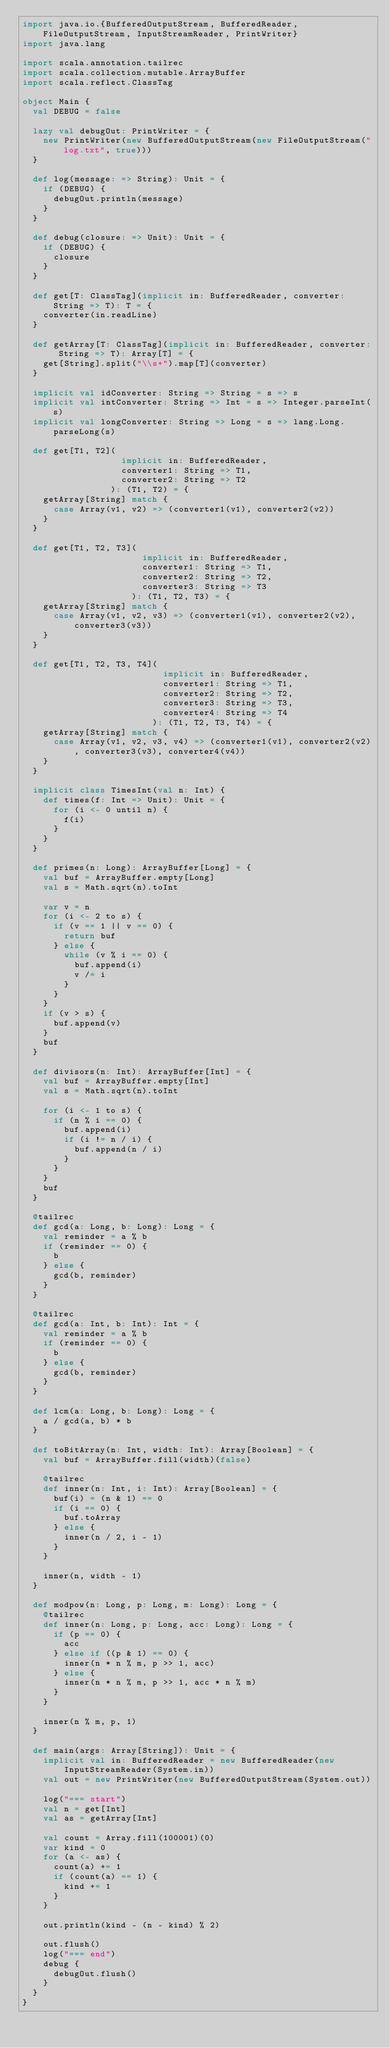Convert code to text. <code><loc_0><loc_0><loc_500><loc_500><_Scala_>import java.io.{BufferedOutputStream, BufferedReader, FileOutputStream, InputStreamReader, PrintWriter}
import java.lang

import scala.annotation.tailrec
import scala.collection.mutable.ArrayBuffer
import scala.reflect.ClassTag

object Main {
  val DEBUG = false

  lazy val debugOut: PrintWriter = {
    new PrintWriter(new BufferedOutputStream(new FileOutputStream("log.txt", true)))
  }

  def log(message: => String): Unit = {
    if (DEBUG) {
      debugOut.println(message)
    }
  }

  def debug(closure: => Unit): Unit = {
    if (DEBUG) {
      closure
    }
  }

  def get[T: ClassTag](implicit in: BufferedReader, converter: String => T): T = {
    converter(in.readLine)
  }

  def getArray[T: ClassTag](implicit in: BufferedReader, converter: String => T): Array[T] = {
    get[String].split("\\s+").map[T](converter)
  }

  implicit val idConverter: String => String = s => s
  implicit val intConverter: String => Int = s => Integer.parseInt(s)
  implicit val longConverter: String => Long = s => lang.Long.parseLong(s)

  def get[T1, T2](
                   implicit in: BufferedReader,
                   converter1: String => T1,
                   converter2: String => T2
                 ): (T1, T2) = {
    getArray[String] match {
      case Array(v1, v2) => (converter1(v1), converter2(v2))
    }
  }

  def get[T1, T2, T3](
                       implicit in: BufferedReader,
                       converter1: String => T1,
                       converter2: String => T2,
                       converter3: String => T3
                     ): (T1, T2, T3) = {
    getArray[String] match {
      case Array(v1, v2, v3) => (converter1(v1), converter2(v2), converter3(v3))
    }
  }

  def get[T1, T2, T3, T4](
                           implicit in: BufferedReader,
                           converter1: String => T1,
                           converter2: String => T2,
                           converter3: String => T3,
                           converter4: String => T4
                         ): (T1, T2, T3, T4) = {
    getArray[String] match {
      case Array(v1, v2, v3, v4) => (converter1(v1), converter2(v2), converter3(v3), converter4(v4))
    }
  }

  implicit class TimesInt(val n: Int) {
    def times(f: Int => Unit): Unit = {
      for (i <- 0 until n) {
        f(i)
      }
    }
  }

  def primes(n: Long): ArrayBuffer[Long] = {
    val buf = ArrayBuffer.empty[Long]
    val s = Math.sqrt(n).toInt

    var v = n
    for (i <- 2 to s) {
      if (v == 1 || v == 0) {
        return buf
      } else {
        while (v % i == 0) {
          buf.append(i)
          v /= i
        }
      }
    }
    if (v > s) {
      buf.append(v)
    }
    buf
  }

  def divisors(n: Int): ArrayBuffer[Int] = {
    val buf = ArrayBuffer.empty[Int]
    val s = Math.sqrt(n).toInt

    for (i <- 1 to s) {
      if (n % i == 0) {
        buf.append(i)
        if (i != n / i) {
          buf.append(n / i)
        }
      }
    }
    buf
  }

  @tailrec
  def gcd(a: Long, b: Long): Long = {
    val reminder = a % b
    if (reminder == 0) {
      b
    } else {
      gcd(b, reminder)
    }
  }

  @tailrec
  def gcd(a: Int, b: Int): Int = {
    val reminder = a % b
    if (reminder == 0) {
      b
    } else {
      gcd(b, reminder)
    }
  }

  def lcm(a: Long, b: Long): Long = {
    a / gcd(a, b) * b
  }

  def toBitArray(n: Int, width: Int): Array[Boolean] = {
    val buf = ArrayBuffer.fill(width)(false)

    @tailrec
    def inner(n: Int, i: Int): Array[Boolean] = {
      buf(i) = (n & 1) == 0
      if (i == 0) {
        buf.toArray
      } else {
        inner(n / 2, i - 1)
      }
    }

    inner(n, width - 1)
  }

  def modpow(n: Long, p: Long, m: Long): Long = {
    @tailrec
    def inner(n: Long, p: Long, acc: Long): Long = {
      if (p == 0) {
        acc
      } else if ((p & 1) == 0) {
        inner(n * n % m, p >> 1, acc)
      } else {
        inner(n * n % m, p >> 1, acc * n % m)
      }
    }

    inner(n % m, p, 1)
  }

  def main(args: Array[String]): Unit = {
    implicit val in: BufferedReader = new BufferedReader(new InputStreamReader(System.in))
    val out = new PrintWriter(new BufferedOutputStream(System.out))

    log("=== start")
    val n = get[Int]
    val as = getArray[Int]

    val count = Array.fill(100001)(0)
    var kind = 0
    for (a <- as) {
      count(a) += 1
      if (count(a) == 1) {
        kind += 1
      }
    }

    out.println(kind - (n - kind) % 2)

    out.flush()
    log("=== end")
    debug {
      debugOut.flush()
    }
  }
}</code> 